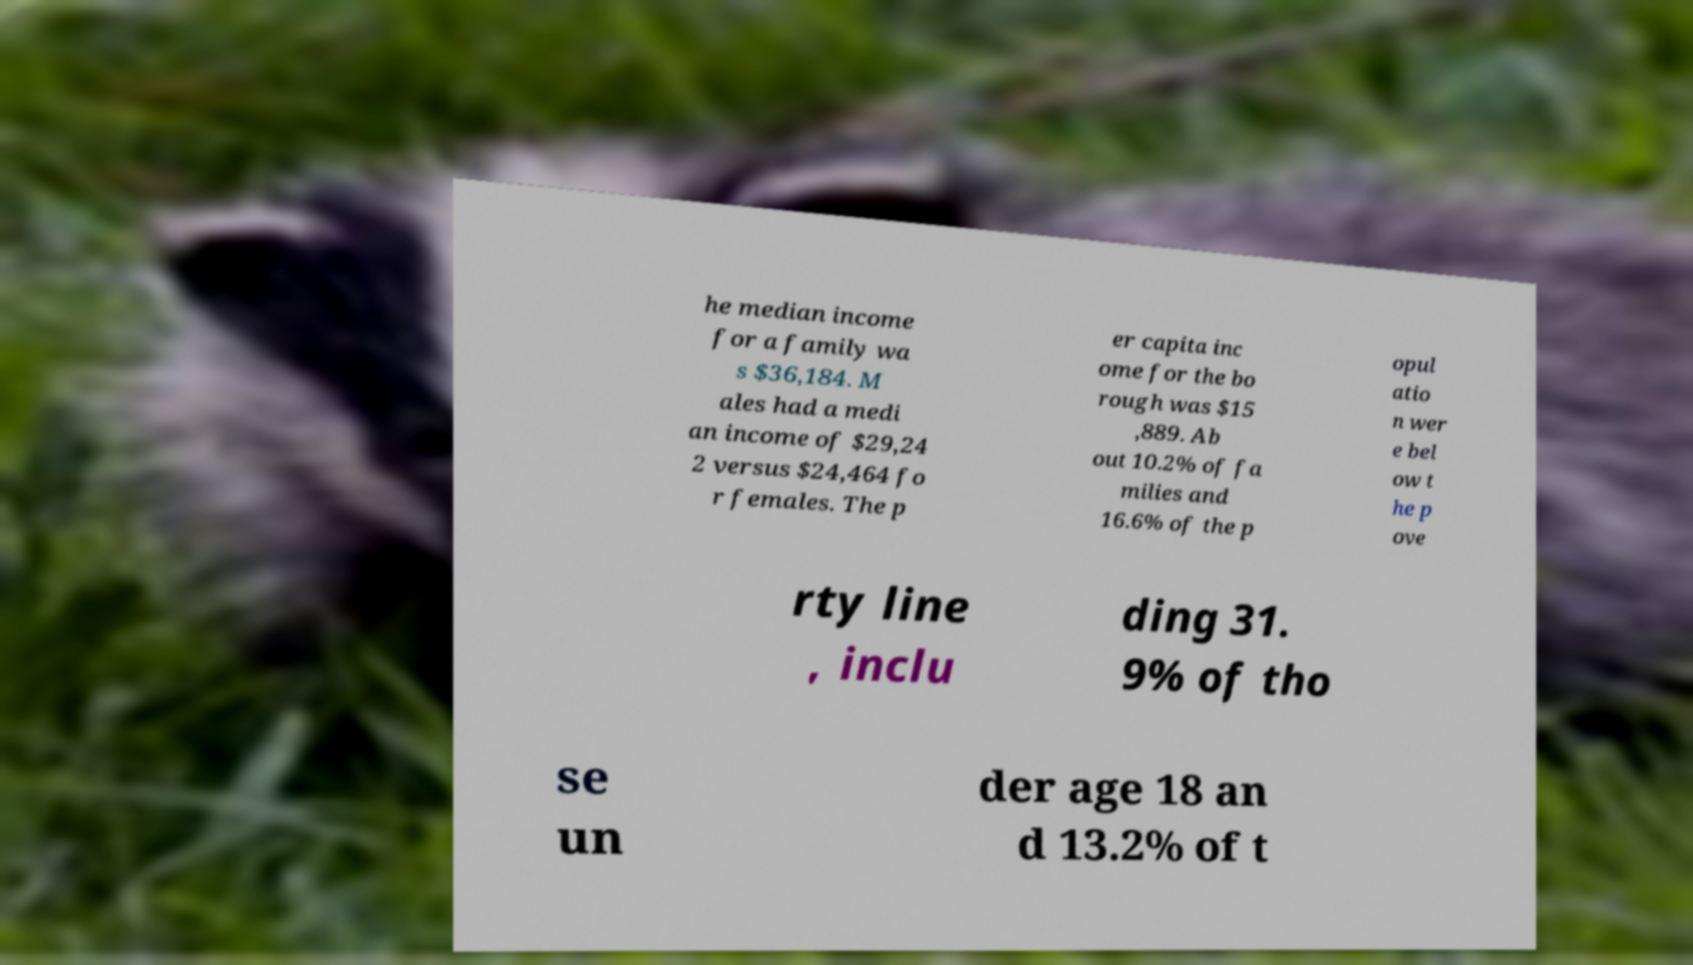What messages or text are displayed in this image? I need them in a readable, typed format. he median income for a family wa s $36,184. M ales had a medi an income of $29,24 2 versus $24,464 fo r females. The p er capita inc ome for the bo rough was $15 ,889. Ab out 10.2% of fa milies and 16.6% of the p opul atio n wer e bel ow t he p ove rty line , inclu ding 31. 9% of tho se un der age 18 an d 13.2% of t 